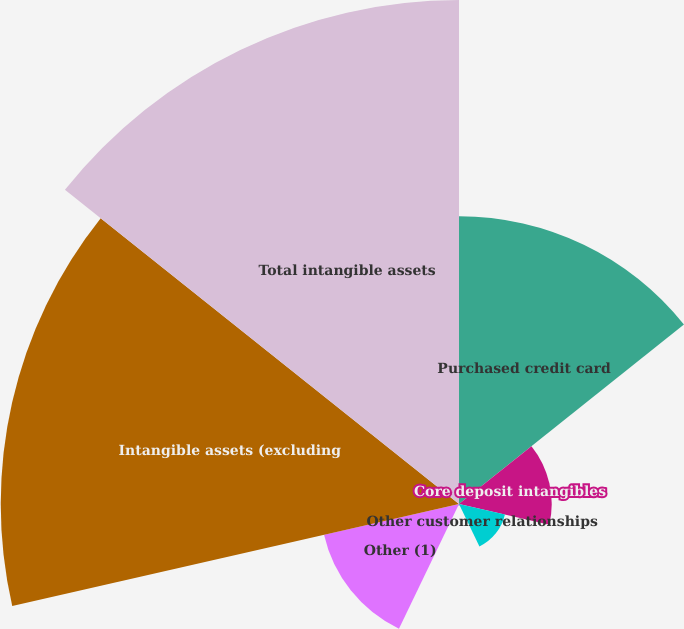<chart> <loc_0><loc_0><loc_500><loc_500><pie_chart><fcel>Purchased credit card<fcel>Core deposit intangibles<fcel>Other customer relationships<fcel>Present value of future<fcel>Other (1)<fcel>Intangible assets (excluding<fcel>Total intangible assets<nl><fcel>18.81%<fcel>6.06%<fcel>3.08%<fcel>0.09%<fcel>9.05%<fcel>29.96%<fcel>32.95%<nl></chart> 